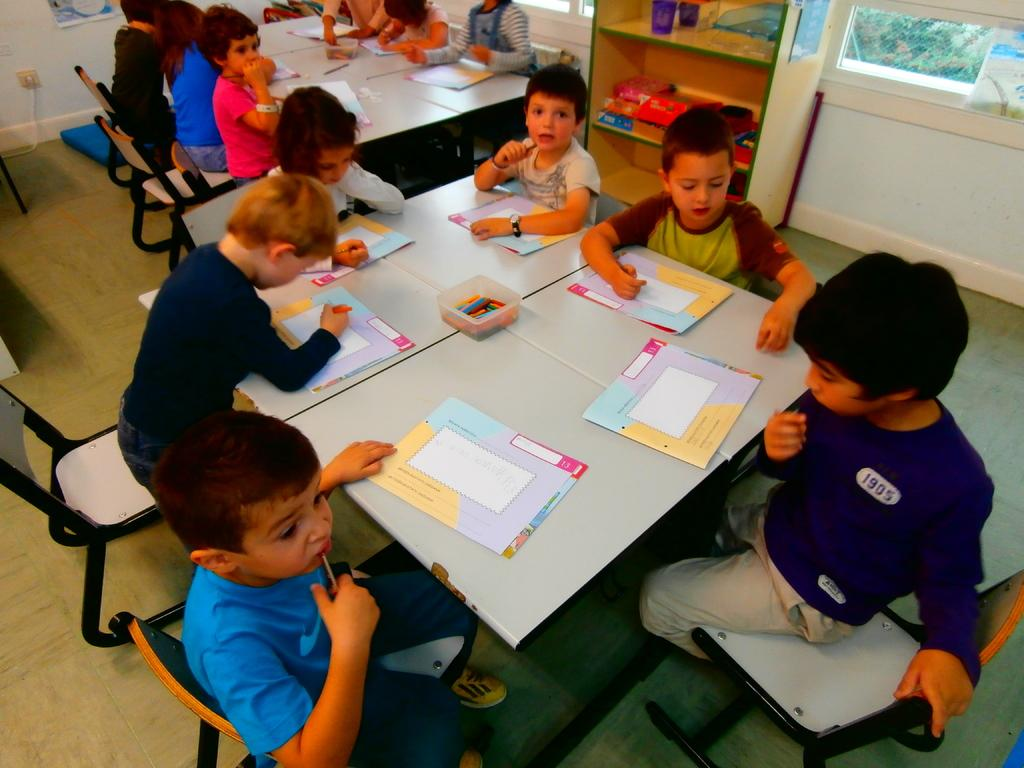What are the people in the image doing? The people in the image are sitting on chairs. What is present in the image besides the people? There is a table in the image. What can be seen on the table? There are books on the table in the image. What type of wrench is being used by the people sitting on chairs in the image? There is no wrench present in the image; the people are sitting on chairs and there are books on the table. How many boys are visible in the image? The provided facts do not mention the gender of the people in the image, so it cannot be determined if there are any boys present. 